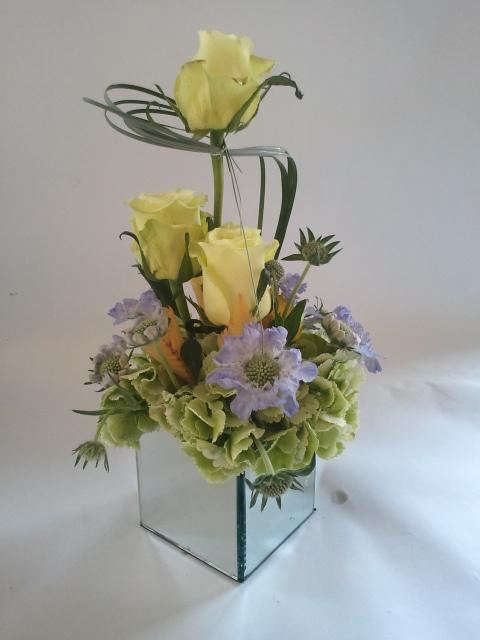What kind of flowers are these?
Be succinct. Roses. Are these flowers made of plastic?
Answer briefly. No. How tall is the flower?
Be succinct. Not very. How many types of flowers are in the display?
Keep it brief. 3. How many flowers are there?
Keep it brief. 6. Is that flower real?
Short answer required. Yes. Is this photo brightly lit?
Concise answer only. Yes. What is the color of the flowers?
Concise answer only. Yellow. How many roses are shown?
Give a very brief answer. 3. What are the flowers sitting in?
Keep it brief. Vase. What color is the flower in the center?
Write a very short answer. Yellow. What kind of flowers are those?
Short answer required. Roses. What color are the flowers?
Short answer required. Yellow and purple. How many flowers are in this scene?
Short answer required. 7. What simple geometric shapes are formed by the lines on the object?
Concise answer only. Square. What color is the largest flour?
Quick response, please. Yellow. What is the vase sitting on?
Short answer required. Table. Does this flower produce pollen?
Be succinct. No. Is the plant container made of a reflective material?
Be succinct. Yes. Are the flowers all the same species?
Give a very brief answer. No. Do you think these flowers are natural?
Short answer required. No. What color are the blossoms?
Write a very short answer. Yellow. How many cats are laying down in the picture?
Write a very short answer. 0. Are these real flowers?
Quick response, please. Yes. What is the shape of the vase?
Keep it brief. Square. 